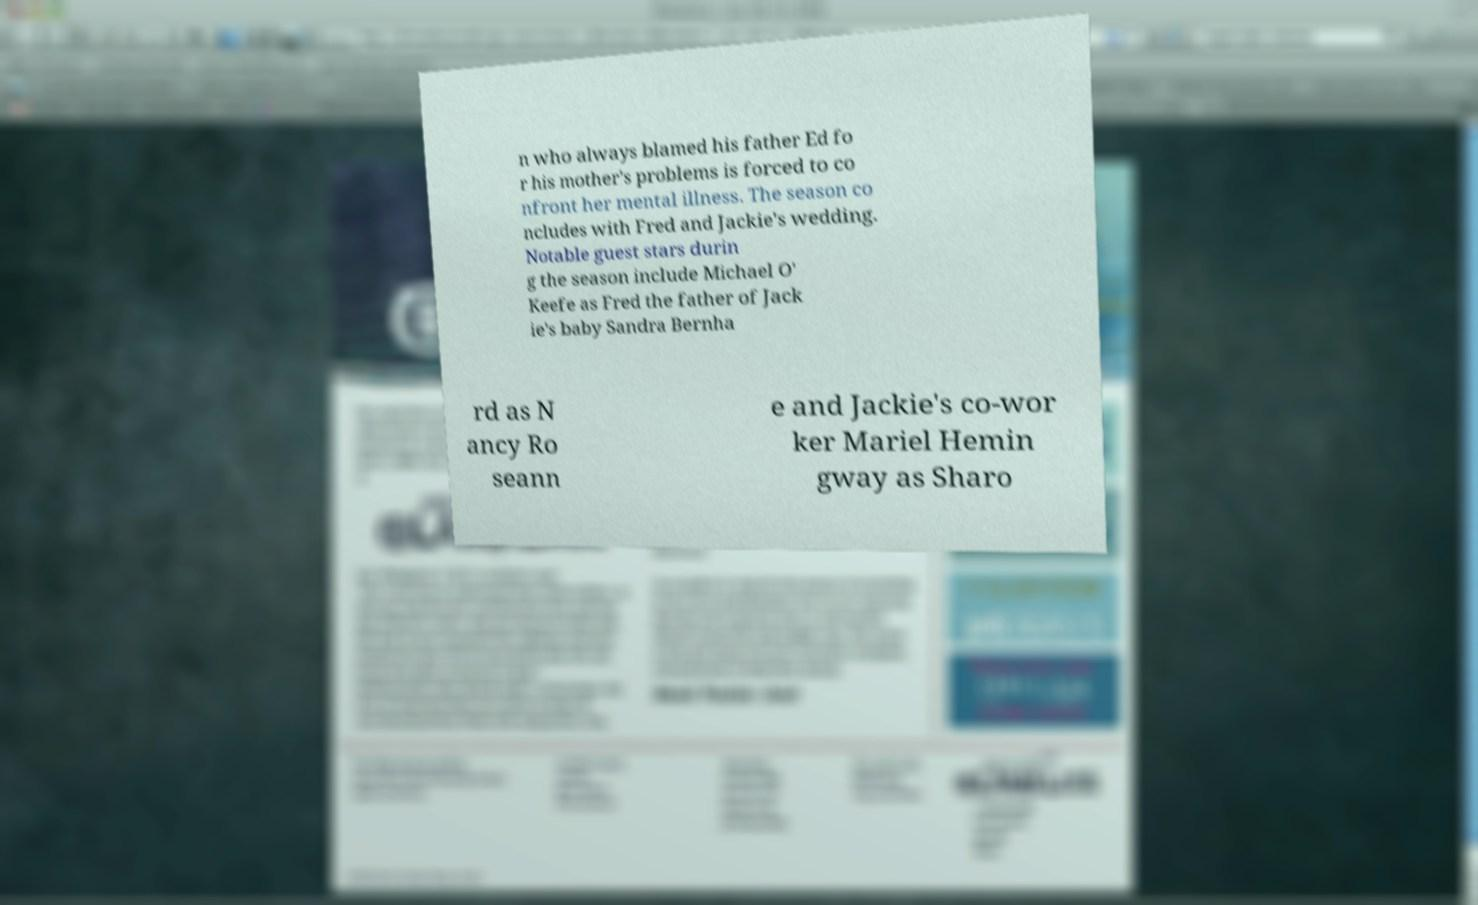For documentation purposes, I need the text within this image transcribed. Could you provide that? n who always blamed his father Ed fo r his mother's problems is forced to co nfront her mental illness. The season co ncludes with Fred and Jackie's wedding. Notable guest stars durin g the season include Michael O' Keefe as Fred the father of Jack ie's baby Sandra Bernha rd as N ancy Ro seann e and Jackie's co-wor ker Mariel Hemin gway as Sharo 